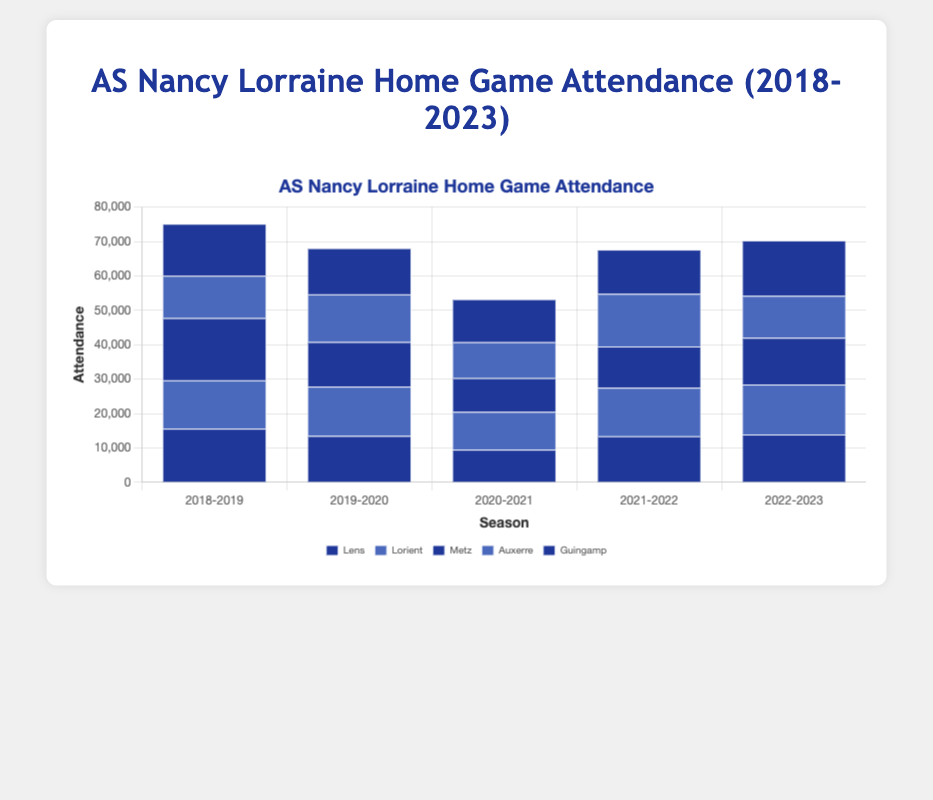What is the highest recorded attendance in the 2018-2019 season? Look for the tallest bar in the 2018-2019 section. The match "Nancy vs Metz" has the highest attendance at 18100.
Answer: 18100 How does the average attendance in the 2020-2021 season compare to the average attendance in the 2022-2023 season? First, calculate the average attendance for each season. For 2020-2021: (9500 + 11000 + 9800 + 10450 + 12500) / 5 = 10650. For 2022-2023: (13900 + 14520 + 13600 + 12200 + 16100) / 5 = 14064. The average attendance in 2022-2023 is higher.
Answer: 2022-2023 is higher What is the total attendance across all matches in the 2019-2020 season? Sum the attendance figures for all matches in the 2019-2020 season: 13500 + 14320 + 12980 + 13840 + 13450 = 68090.
Answer: 68090 Which match had the lowest attendance in the 2021-2022 season? Find the shortest bar in the 2021-2022 section. The match "Nancy vs Pau FC" has the lowest attendance at 11980.
Answer: Nancy vs Pau FC If you combine the attendance of "Nancy vs Lens" and "Nancy vs Metz" in the 2018-2019 season, what is the total? Sum the attendance figures for "Nancy vs Lens" and "Nancy vs Metz": 15600 + 18100 = 33700.
Answer: 33700 Did the attendance for matches against Toulouse increase or decrease between the 2020-2021 and 2022-2023 seasons? Compare the attendance for "Nancy vs Toulouse" in 2020-2021 (12500) with 2022-2023 (16100). It increased.
Answer: Increased What is the visual difference between the attendance bars for the 2020-2021 season compared to other seasons? The bars for 2020-2021 are generally shorter than those for other seasons, indicating lower attendance.
Answer: Shorter bars What is the difference in attendance between the highest and lowest attended match in the 2018-2019 season? Find the highest (Nancy vs Metz: 18100) and lowest (Nancy vs Auxerre: 12300) attended matches in 2018-2019 and calculate the difference: 18100 - 12300 = 5800.
Answer: 5800 Which season had the most consistent attendance figures, as indicated by the height of the bars? The 2019-2020 season shows the most consistent attendance, with bar heights close to each other.
Answer: 2019-2020 Compare the attendance for matches against Lorient in the 2018-2019 and Nimes in the 2021-2022 seasons. Which one is higher? Check the attendance values for "Nancy vs Lorient" (14050) in 2018-2019 and "Nancy vs Nimes" (14100) in 2021-2022. The attendance for "Nancy vs Nimes" is higher.
Answer: Nancy vs Nimes 